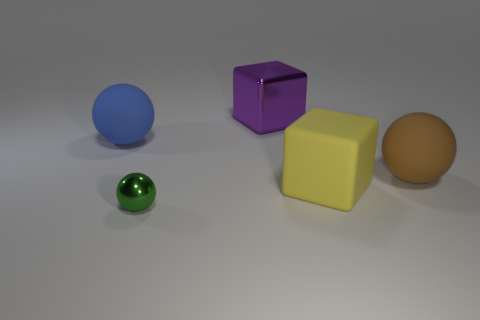What color is the largest block in the scene, and where is it located? The largest block in the scene is beige. It's centrally located towards the back of the image, between the purple cube and the yellow cube. 